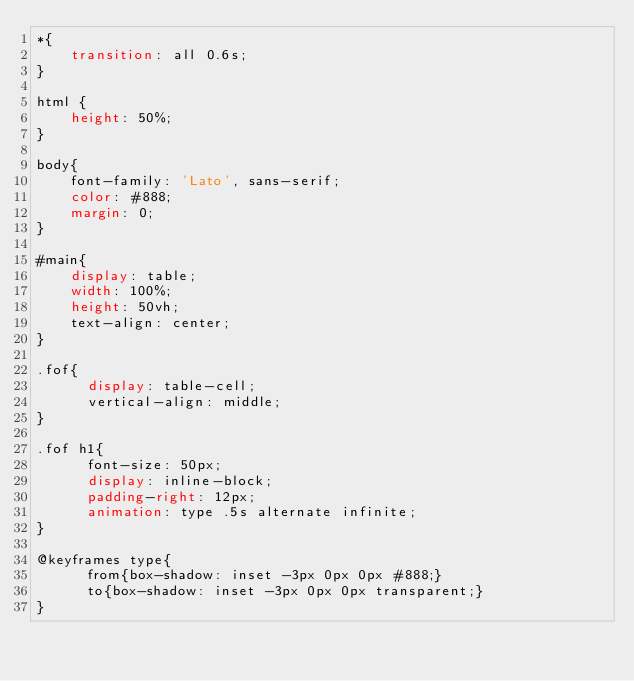<code> <loc_0><loc_0><loc_500><loc_500><_CSS_>*{
    transition: all 0.6s;
}

html {
    height: 50%;
}

body{
    font-family: 'Lato', sans-serif;
    color: #888;
    margin: 0;
}

#main{
    display: table;
    width: 100%;
    height: 50vh;
    text-align: center;
}

.fof{
	  display: table-cell;
	  vertical-align: middle;
}

.fof h1{
	  font-size: 50px;
	  display: inline-block;
	  padding-right: 12px;
	  animation: type .5s alternate infinite;
}

@keyframes type{
	  from{box-shadow: inset -3px 0px 0px #888;}
	  to{box-shadow: inset -3px 0px 0px transparent;}
}</code> 